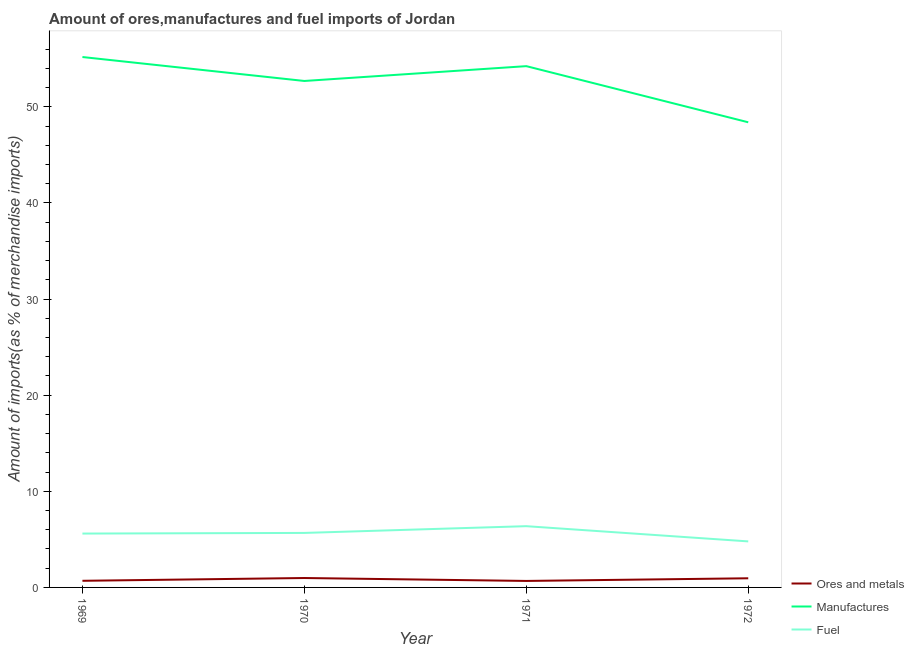Is the number of lines equal to the number of legend labels?
Keep it short and to the point. Yes. What is the percentage of fuel imports in 1969?
Ensure brevity in your answer.  5.6. Across all years, what is the maximum percentage of manufactures imports?
Keep it short and to the point. 55.19. Across all years, what is the minimum percentage of manufactures imports?
Give a very brief answer. 48.4. In which year was the percentage of manufactures imports maximum?
Make the answer very short. 1969. In which year was the percentage of ores and metals imports minimum?
Your answer should be very brief. 1971. What is the total percentage of ores and metals imports in the graph?
Your answer should be very brief. 3.3. What is the difference between the percentage of fuel imports in 1971 and that in 1972?
Ensure brevity in your answer.  1.58. What is the difference between the percentage of ores and metals imports in 1971 and the percentage of manufactures imports in 1972?
Offer a very short reply. -47.72. What is the average percentage of ores and metals imports per year?
Your response must be concise. 0.82. In the year 1972, what is the difference between the percentage of fuel imports and percentage of ores and metals imports?
Your response must be concise. 3.84. What is the ratio of the percentage of ores and metals imports in 1970 to that in 1971?
Make the answer very short. 1.45. Is the percentage of fuel imports in 1971 less than that in 1972?
Offer a very short reply. No. What is the difference between the highest and the second highest percentage of ores and metals imports?
Ensure brevity in your answer.  0.03. What is the difference between the highest and the lowest percentage of fuel imports?
Provide a short and direct response. 1.58. In how many years, is the percentage of ores and metals imports greater than the average percentage of ores and metals imports taken over all years?
Your response must be concise. 2. Is the sum of the percentage of ores and metals imports in 1970 and 1972 greater than the maximum percentage of manufactures imports across all years?
Offer a terse response. No. Is the percentage of fuel imports strictly greater than the percentage of ores and metals imports over the years?
Offer a very short reply. Yes. Is the percentage of manufactures imports strictly less than the percentage of fuel imports over the years?
Ensure brevity in your answer.  No. What is the difference between two consecutive major ticks on the Y-axis?
Keep it short and to the point. 10. Does the graph contain grids?
Provide a succinct answer. No. Where does the legend appear in the graph?
Your response must be concise. Bottom right. What is the title of the graph?
Ensure brevity in your answer.  Amount of ores,manufactures and fuel imports of Jordan. Does "Renewable sources" appear as one of the legend labels in the graph?
Offer a terse response. No. What is the label or title of the Y-axis?
Make the answer very short. Amount of imports(as % of merchandise imports). What is the Amount of imports(as % of merchandise imports) of Ores and metals in 1969?
Keep it short and to the point. 0.69. What is the Amount of imports(as % of merchandise imports) of Manufactures in 1969?
Give a very brief answer. 55.19. What is the Amount of imports(as % of merchandise imports) in Fuel in 1969?
Make the answer very short. 5.6. What is the Amount of imports(as % of merchandise imports) of Ores and metals in 1970?
Keep it short and to the point. 0.98. What is the Amount of imports(as % of merchandise imports) of Manufactures in 1970?
Make the answer very short. 52.69. What is the Amount of imports(as % of merchandise imports) in Fuel in 1970?
Provide a succinct answer. 5.67. What is the Amount of imports(as % of merchandise imports) of Ores and metals in 1971?
Provide a short and direct response. 0.67. What is the Amount of imports(as % of merchandise imports) of Manufactures in 1971?
Offer a very short reply. 54.24. What is the Amount of imports(as % of merchandise imports) of Fuel in 1971?
Provide a succinct answer. 6.37. What is the Amount of imports(as % of merchandise imports) of Ores and metals in 1972?
Your response must be concise. 0.95. What is the Amount of imports(as % of merchandise imports) of Manufactures in 1972?
Offer a very short reply. 48.4. What is the Amount of imports(as % of merchandise imports) of Fuel in 1972?
Provide a succinct answer. 4.79. Across all years, what is the maximum Amount of imports(as % of merchandise imports) of Ores and metals?
Offer a very short reply. 0.98. Across all years, what is the maximum Amount of imports(as % of merchandise imports) in Manufactures?
Your response must be concise. 55.19. Across all years, what is the maximum Amount of imports(as % of merchandise imports) of Fuel?
Provide a succinct answer. 6.37. Across all years, what is the minimum Amount of imports(as % of merchandise imports) of Ores and metals?
Your answer should be very brief. 0.67. Across all years, what is the minimum Amount of imports(as % of merchandise imports) in Manufactures?
Provide a short and direct response. 48.4. Across all years, what is the minimum Amount of imports(as % of merchandise imports) of Fuel?
Keep it short and to the point. 4.79. What is the total Amount of imports(as % of merchandise imports) in Ores and metals in the graph?
Offer a very short reply. 3.3. What is the total Amount of imports(as % of merchandise imports) of Manufactures in the graph?
Provide a short and direct response. 210.51. What is the total Amount of imports(as % of merchandise imports) of Fuel in the graph?
Your answer should be very brief. 22.44. What is the difference between the Amount of imports(as % of merchandise imports) of Ores and metals in 1969 and that in 1970?
Ensure brevity in your answer.  -0.29. What is the difference between the Amount of imports(as % of merchandise imports) of Manufactures in 1969 and that in 1970?
Provide a succinct answer. 2.49. What is the difference between the Amount of imports(as % of merchandise imports) of Fuel in 1969 and that in 1970?
Provide a short and direct response. -0.07. What is the difference between the Amount of imports(as % of merchandise imports) in Ores and metals in 1969 and that in 1971?
Your answer should be very brief. 0.02. What is the difference between the Amount of imports(as % of merchandise imports) of Manufactures in 1969 and that in 1971?
Your response must be concise. 0.95. What is the difference between the Amount of imports(as % of merchandise imports) of Fuel in 1969 and that in 1971?
Keep it short and to the point. -0.77. What is the difference between the Amount of imports(as % of merchandise imports) of Ores and metals in 1969 and that in 1972?
Provide a short and direct response. -0.26. What is the difference between the Amount of imports(as % of merchandise imports) in Manufactures in 1969 and that in 1972?
Make the answer very short. 6.79. What is the difference between the Amount of imports(as % of merchandise imports) in Fuel in 1969 and that in 1972?
Offer a terse response. 0.82. What is the difference between the Amount of imports(as % of merchandise imports) in Ores and metals in 1970 and that in 1971?
Offer a terse response. 0.3. What is the difference between the Amount of imports(as % of merchandise imports) in Manufactures in 1970 and that in 1971?
Ensure brevity in your answer.  -1.54. What is the difference between the Amount of imports(as % of merchandise imports) of Fuel in 1970 and that in 1971?
Provide a succinct answer. -0.7. What is the difference between the Amount of imports(as % of merchandise imports) of Ores and metals in 1970 and that in 1972?
Provide a short and direct response. 0.03. What is the difference between the Amount of imports(as % of merchandise imports) in Manufactures in 1970 and that in 1972?
Your response must be concise. 4.3. What is the difference between the Amount of imports(as % of merchandise imports) of Fuel in 1970 and that in 1972?
Provide a succinct answer. 0.88. What is the difference between the Amount of imports(as % of merchandise imports) in Ores and metals in 1971 and that in 1972?
Your answer should be very brief. -0.28. What is the difference between the Amount of imports(as % of merchandise imports) in Manufactures in 1971 and that in 1972?
Provide a succinct answer. 5.84. What is the difference between the Amount of imports(as % of merchandise imports) in Fuel in 1971 and that in 1972?
Your answer should be very brief. 1.58. What is the difference between the Amount of imports(as % of merchandise imports) of Ores and metals in 1969 and the Amount of imports(as % of merchandise imports) of Manufactures in 1970?
Make the answer very short. -52. What is the difference between the Amount of imports(as % of merchandise imports) in Ores and metals in 1969 and the Amount of imports(as % of merchandise imports) in Fuel in 1970?
Offer a very short reply. -4.98. What is the difference between the Amount of imports(as % of merchandise imports) of Manufactures in 1969 and the Amount of imports(as % of merchandise imports) of Fuel in 1970?
Ensure brevity in your answer.  49.52. What is the difference between the Amount of imports(as % of merchandise imports) of Ores and metals in 1969 and the Amount of imports(as % of merchandise imports) of Manufactures in 1971?
Provide a succinct answer. -53.55. What is the difference between the Amount of imports(as % of merchandise imports) of Ores and metals in 1969 and the Amount of imports(as % of merchandise imports) of Fuel in 1971?
Your response must be concise. -5.68. What is the difference between the Amount of imports(as % of merchandise imports) in Manufactures in 1969 and the Amount of imports(as % of merchandise imports) in Fuel in 1971?
Provide a succinct answer. 48.81. What is the difference between the Amount of imports(as % of merchandise imports) in Ores and metals in 1969 and the Amount of imports(as % of merchandise imports) in Manufactures in 1972?
Keep it short and to the point. -47.71. What is the difference between the Amount of imports(as % of merchandise imports) of Ores and metals in 1969 and the Amount of imports(as % of merchandise imports) of Fuel in 1972?
Offer a very short reply. -4.1. What is the difference between the Amount of imports(as % of merchandise imports) in Manufactures in 1969 and the Amount of imports(as % of merchandise imports) in Fuel in 1972?
Provide a short and direct response. 50.4. What is the difference between the Amount of imports(as % of merchandise imports) of Ores and metals in 1970 and the Amount of imports(as % of merchandise imports) of Manufactures in 1971?
Keep it short and to the point. -53.26. What is the difference between the Amount of imports(as % of merchandise imports) in Ores and metals in 1970 and the Amount of imports(as % of merchandise imports) in Fuel in 1971?
Offer a terse response. -5.39. What is the difference between the Amount of imports(as % of merchandise imports) of Manufactures in 1970 and the Amount of imports(as % of merchandise imports) of Fuel in 1971?
Your response must be concise. 46.32. What is the difference between the Amount of imports(as % of merchandise imports) in Ores and metals in 1970 and the Amount of imports(as % of merchandise imports) in Manufactures in 1972?
Keep it short and to the point. -47.42. What is the difference between the Amount of imports(as % of merchandise imports) of Ores and metals in 1970 and the Amount of imports(as % of merchandise imports) of Fuel in 1972?
Your answer should be very brief. -3.81. What is the difference between the Amount of imports(as % of merchandise imports) of Manufactures in 1970 and the Amount of imports(as % of merchandise imports) of Fuel in 1972?
Make the answer very short. 47.91. What is the difference between the Amount of imports(as % of merchandise imports) in Ores and metals in 1971 and the Amount of imports(as % of merchandise imports) in Manufactures in 1972?
Provide a succinct answer. -47.72. What is the difference between the Amount of imports(as % of merchandise imports) in Ores and metals in 1971 and the Amount of imports(as % of merchandise imports) in Fuel in 1972?
Your answer should be compact. -4.11. What is the difference between the Amount of imports(as % of merchandise imports) in Manufactures in 1971 and the Amount of imports(as % of merchandise imports) in Fuel in 1972?
Your response must be concise. 49.45. What is the average Amount of imports(as % of merchandise imports) of Ores and metals per year?
Provide a short and direct response. 0.82. What is the average Amount of imports(as % of merchandise imports) in Manufactures per year?
Offer a terse response. 52.63. What is the average Amount of imports(as % of merchandise imports) in Fuel per year?
Provide a short and direct response. 5.61. In the year 1969, what is the difference between the Amount of imports(as % of merchandise imports) of Ores and metals and Amount of imports(as % of merchandise imports) of Manufactures?
Keep it short and to the point. -54.5. In the year 1969, what is the difference between the Amount of imports(as % of merchandise imports) of Ores and metals and Amount of imports(as % of merchandise imports) of Fuel?
Provide a short and direct response. -4.91. In the year 1969, what is the difference between the Amount of imports(as % of merchandise imports) in Manufactures and Amount of imports(as % of merchandise imports) in Fuel?
Keep it short and to the point. 49.58. In the year 1970, what is the difference between the Amount of imports(as % of merchandise imports) in Ores and metals and Amount of imports(as % of merchandise imports) in Manufactures?
Provide a short and direct response. -51.72. In the year 1970, what is the difference between the Amount of imports(as % of merchandise imports) of Ores and metals and Amount of imports(as % of merchandise imports) of Fuel?
Your response must be concise. -4.69. In the year 1970, what is the difference between the Amount of imports(as % of merchandise imports) of Manufactures and Amount of imports(as % of merchandise imports) of Fuel?
Ensure brevity in your answer.  47.02. In the year 1971, what is the difference between the Amount of imports(as % of merchandise imports) of Ores and metals and Amount of imports(as % of merchandise imports) of Manufactures?
Offer a very short reply. -53.56. In the year 1971, what is the difference between the Amount of imports(as % of merchandise imports) in Ores and metals and Amount of imports(as % of merchandise imports) in Fuel?
Provide a succinct answer. -5.7. In the year 1971, what is the difference between the Amount of imports(as % of merchandise imports) in Manufactures and Amount of imports(as % of merchandise imports) in Fuel?
Your answer should be compact. 47.86. In the year 1972, what is the difference between the Amount of imports(as % of merchandise imports) of Ores and metals and Amount of imports(as % of merchandise imports) of Manufactures?
Your answer should be compact. -47.44. In the year 1972, what is the difference between the Amount of imports(as % of merchandise imports) of Ores and metals and Amount of imports(as % of merchandise imports) of Fuel?
Keep it short and to the point. -3.84. In the year 1972, what is the difference between the Amount of imports(as % of merchandise imports) of Manufactures and Amount of imports(as % of merchandise imports) of Fuel?
Ensure brevity in your answer.  43.61. What is the ratio of the Amount of imports(as % of merchandise imports) of Ores and metals in 1969 to that in 1970?
Offer a very short reply. 0.7. What is the ratio of the Amount of imports(as % of merchandise imports) in Manufactures in 1969 to that in 1970?
Your answer should be compact. 1.05. What is the ratio of the Amount of imports(as % of merchandise imports) in Fuel in 1969 to that in 1970?
Your answer should be compact. 0.99. What is the ratio of the Amount of imports(as % of merchandise imports) in Ores and metals in 1969 to that in 1971?
Keep it short and to the point. 1.02. What is the ratio of the Amount of imports(as % of merchandise imports) in Manufactures in 1969 to that in 1971?
Give a very brief answer. 1.02. What is the ratio of the Amount of imports(as % of merchandise imports) in Fuel in 1969 to that in 1971?
Provide a short and direct response. 0.88. What is the ratio of the Amount of imports(as % of merchandise imports) of Ores and metals in 1969 to that in 1972?
Provide a short and direct response. 0.72. What is the ratio of the Amount of imports(as % of merchandise imports) of Manufactures in 1969 to that in 1972?
Make the answer very short. 1.14. What is the ratio of the Amount of imports(as % of merchandise imports) in Fuel in 1969 to that in 1972?
Your response must be concise. 1.17. What is the ratio of the Amount of imports(as % of merchandise imports) in Ores and metals in 1970 to that in 1971?
Offer a very short reply. 1.45. What is the ratio of the Amount of imports(as % of merchandise imports) in Manufactures in 1970 to that in 1971?
Your answer should be very brief. 0.97. What is the ratio of the Amount of imports(as % of merchandise imports) of Fuel in 1970 to that in 1971?
Provide a succinct answer. 0.89. What is the ratio of the Amount of imports(as % of merchandise imports) in Ores and metals in 1970 to that in 1972?
Provide a succinct answer. 1.03. What is the ratio of the Amount of imports(as % of merchandise imports) of Manufactures in 1970 to that in 1972?
Ensure brevity in your answer.  1.09. What is the ratio of the Amount of imports(as % of merchandise imports) of Fuel in 1970 to that in 1972?
Offer a terse response. 1.18. What is the ratio of the Amount of imports(as % of merchandise imports) in Ores and metals in 1971 to that in 1972?
Make the answer very short. 0.71. What is the ratio of the Amount of imports(as % of merchandise imports) of Manufactures in 1971 to that in 1972?
Offer a terse response. 1.12. What is the ratio of the Amount of imports(as % of merchandise imports) of Fuel in 1971 to that in 1972?
Ensure brevity in your answer.  1.33. What is the difference between the highest and the second highest Amount of imports(as % of merchandise imports) of Ores and metals?
Your answer should be very brief. 0.03. What is the difference between the highest and the second highest Amount of imports(as % of merchandise imports) of Manufactures?
Your answer should be compact. 0.95. What is the difference between the highest and the second highest Amount of imports(as % of merchandise imports) of Fuel?
Your answer should be compact. 0.7. What is the difference between the highest and the lowest Amount of imports(as % of merchandise imports) of Ores and metals?
Provide a succinct answer. 0.3. What is the difference between the highest and the lowest Amount of imports(as % of merchandise imports) of Manufactures?
Your response must be concise. 6.79. What is the difference between the highest and the lowest Amount of imports(as % of merchandise imports) in Fuel?
Give a very brief answer. 1.58. 